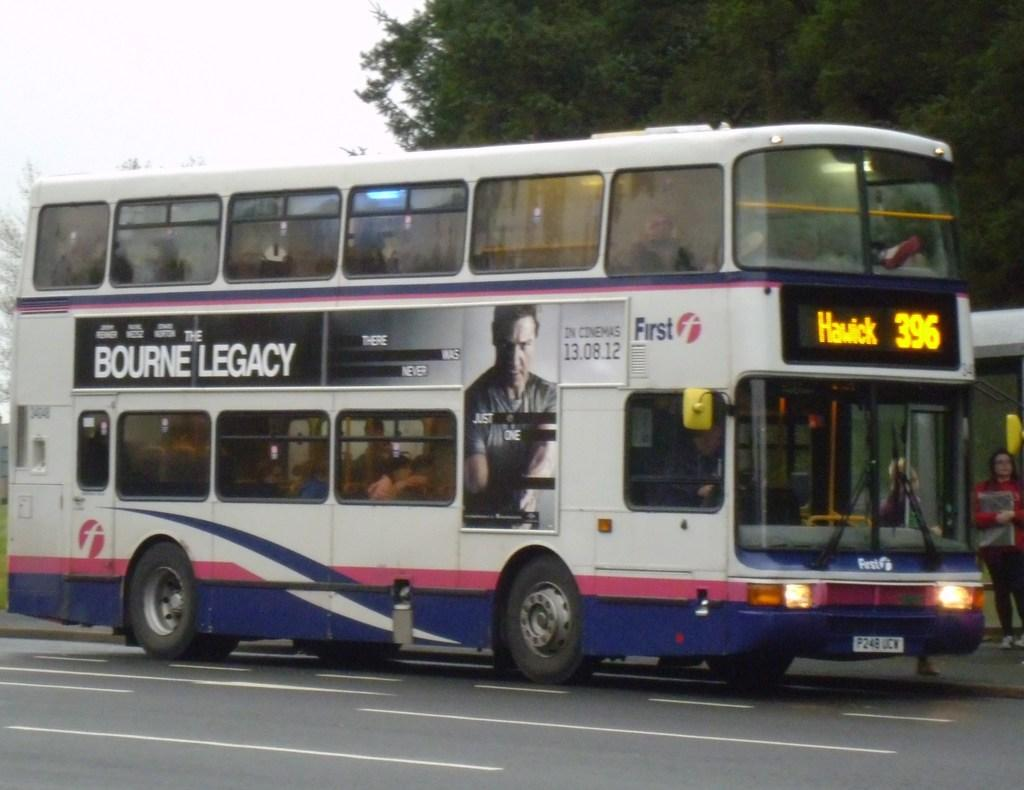<image>
Relay a brief, clear account of the picture shown. A double decker bus with the number 396 on the front 